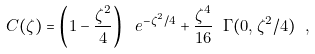Convert formula to latex. <formula><loc_0><loc_0><loc_500><loc_500>C ( \zeta ) = \left ( 1 - \frac { \zeta ^ { 2 } } { 4 } \right ) \ e ^ { - \zeta ^ { 2 } / 4 } + \frac { \zeta ^ { 4 } } { 1 6 } \ \Gamma ( 0 , \zeta ^ { 2 } / 4 ) \ ,</formula> 